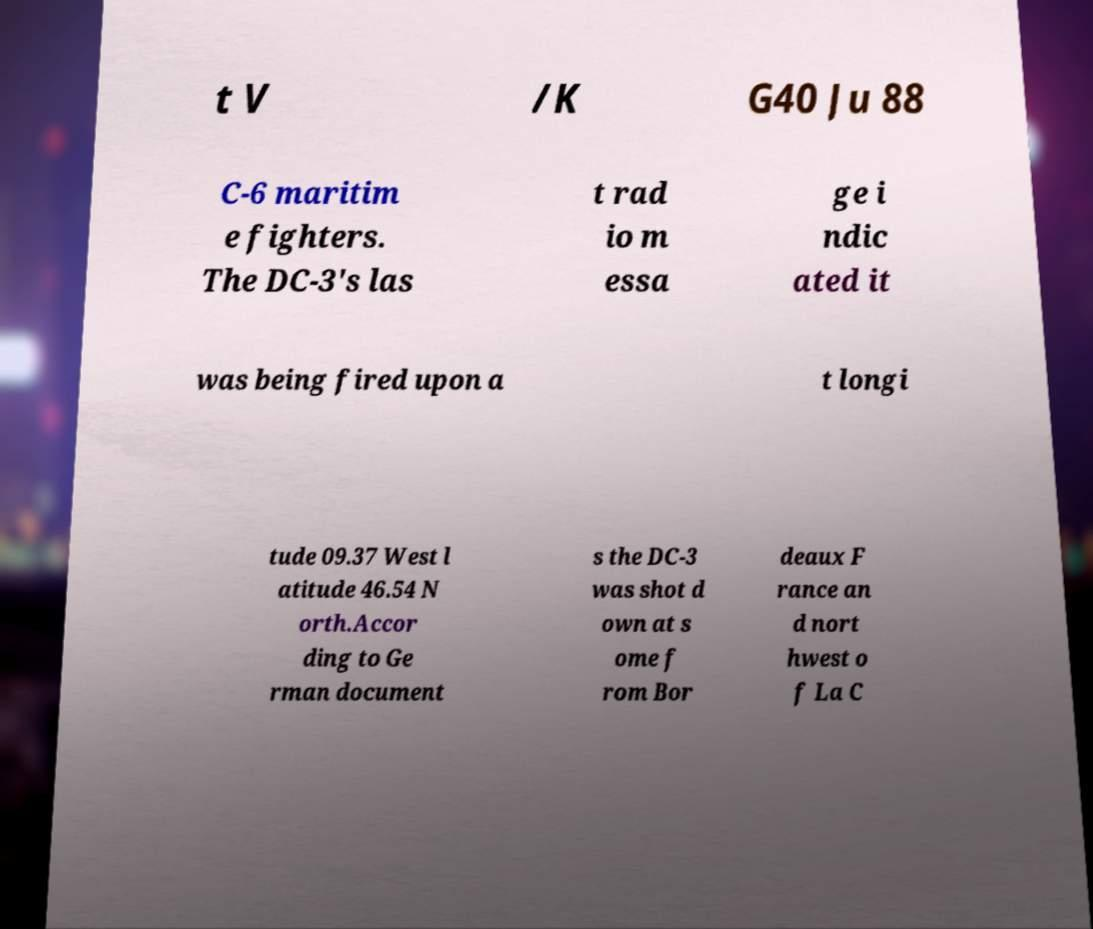Please identify and transcribe the text found in this image. t V /K G40 Ju 88 C-6 maritim e fighters. The DC-3's las t rad io m essa ge i ndic ated it was being fired upon a t longi tude 09.37 West l atitude 46.54 N orth.Accor ding to Ge rman document s the DC-3 was shot d own at s ome f rom Bor deaux F rance an d nort hwest o f La C 